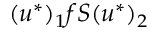<formula> <loc_0><loc_0><loc_500><loc_500>( u ^ { \ast } ) _ { 1 } f S ( u ^ { \ast } ) _ { 2 }</formula> 